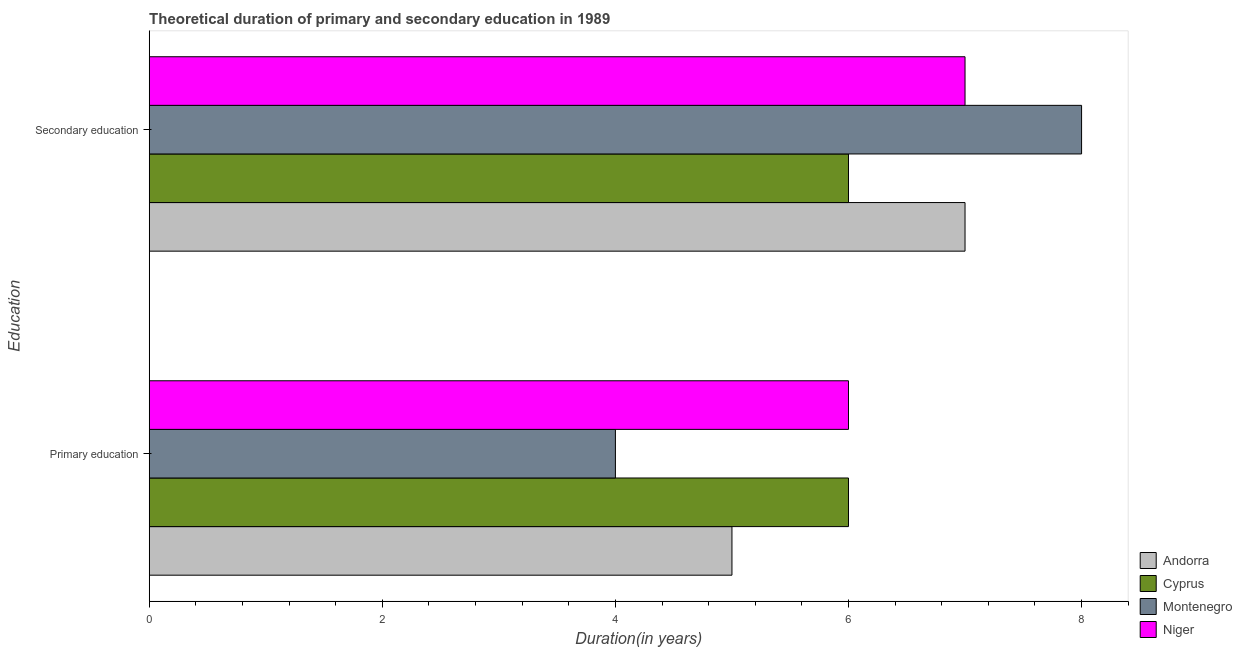How many groups of bars are there?
Provide a succinct answer. 2. How many bars are there on the 1st tick from the top?
Provide a succinct answer. 4. What is the label of the 1st group of bars from the top?
Give a very brief answer. Secondary education. What is the duration of secondary education in Niger?
Provide a succinct answer. 7. Across all countries, what is the minimum duration of primary education?
Your response must be concise. 4. In which country was the duration of primary education maximum?
Ensure brevity in your answer.  Cyprus. In which country was the duration of primary education minimum?
Provide a succinct answer. Montenegro. What is the total duration of primary education in the graph?
Provide a short and direct response. 21. What is the difference between the duration of secondary education in Montenegro and the duration of primary education in Cyprus?
Give a very brief answer. 2. What is the average duration of primary education per country?
Make the answer very short. 5.25. What is the difference between the duration of primary education and duration of secondary education in Cyprus?
Keep it short and to the point. 0. In how many countries, is the duration of secondary education greater than 3.2 years?
Provide a short and direct response. 4. Is the duration of secondary education in Andorra less than that in Cyprus?
Your response must be concise. No. What does the 3rd bar from the top in Primary education represents?
Provide a succinct answer. Cyprus. What does the 3rd bar from the bottom in Secondary education represents?
Your response must be concise. Montenegro. Are the values on the major ticks of X-axis written in scientific E-notation?
Your response must be concise. No. Does the graph contain grids?
Your answer should be very brief. No. How are the legend labels stacked?
Give a very brief answer. Vertical. What is the title of the graph?
Your response must be concise. Theoretical duration of primary and secondary education in 1989. Does "Macedonia" appear as one of the legend labels in the graph?
Provide a short and direct response. No. What is the label or title of the X-axis?
Your answer should be very brief. Duration(in years). What is the label or title of the Y-axis?
Offer a terse response. Education. What is the Duration(in years) of Andorra in Primary education?
Ensure brevity in your answer.  5. What is the Duration(in years) of Cyprus in Primary education?
Your answer should be compact. 6. What is the Duration(in years) in Andorra in Secondary education?
Offer a very short reply. 7. What is the Duration(in years) of Cyprus in Secondary education?
Offer a terse response. 6. What is the Duration(in years) in Montenegro in Secondary education?
Your response must be concise. 8. What is the Duration(in years) in Niger in Secondary education?
Provide a succinct answer. 7. Across all Education, what is the maximum Duration(in years) of Andorra?
Your answer should be compact. 7. Across all Education, what is the maximum Duration(in years) of Cyprus?
Provide a succinct answer. 6. Across all Education, what is the minimum Duration(in years) of Cyprus?
Provide a succinct answer. 6. What is the total Duration(in years) in Andorra in the graph?
Your answer should be very brief. 12. What is the total Duration(in years) of Cyprus in the graph?
Give a very brief answer. 12. What is the difference between the Duration(in years) of Niger in Primary education and that in Secondary education?
Your answer should be very brief. -1. What is the difference between the Duration(in years) of Andorra in Primary education and the Duration(in years) of Cyprus in Secondary education?
Provide a succinct answer. -1. What is the difference between the Duration(in years) of Andorra in Primary education and the Duration(in years) of Niger in Secondary education?
Offer a terse response. -2. What is the difference between the Duration(in years) of Montenegro in Primary education and the Duration(in years) of Niger in Secondary education?
Offer a very short reply. -3. What is the average Duration(in years) in Andorra per Education?
Keep it short and to the point. 6. What is the average Duration(in years) in Montenegro per Education?
Keep it short and to the point. 6. What is the difference between the Duration(in years) of Andorra and Duration(in years) of Cyprus in Primary education?
Your response must be concise. -1. What is the difference between the Duration(in years) of Andorra and Duration(in years) of Montenegro in Primary education?
Ensure brevity in your answer.  1. What is the difference between the Duration(in years) of Montenegro and Duration(in years) of Niger in Primary education?
Provide a short and direct response. -2. What is the difference between the Duration(in years) of Andorra and Duration(in years) of Niger in Secondary education?
Keep it short and to the point. 0. What is the difference between the Duration(in years) of Cyprus and Duration(in years) of Montenegro in Secondary education?
Provide a succinct answer. -2. What is the ratio of the Duration(in years) in Andorra in Primary education to that in Secondary education?
Offer a very short reply. 0.71. What is the ratio of the Duration(in years) of Montenegro in Primary education to that in Secondary education?
Give a very brief answer. 0.5. What is the difference between the highest and the second highest Duration(in years) in Andorra?
Offer a terse response. 2. What is the difference between the highest and the lowest Duration(in years) in Andorra?
Offer a terse response. 2. 